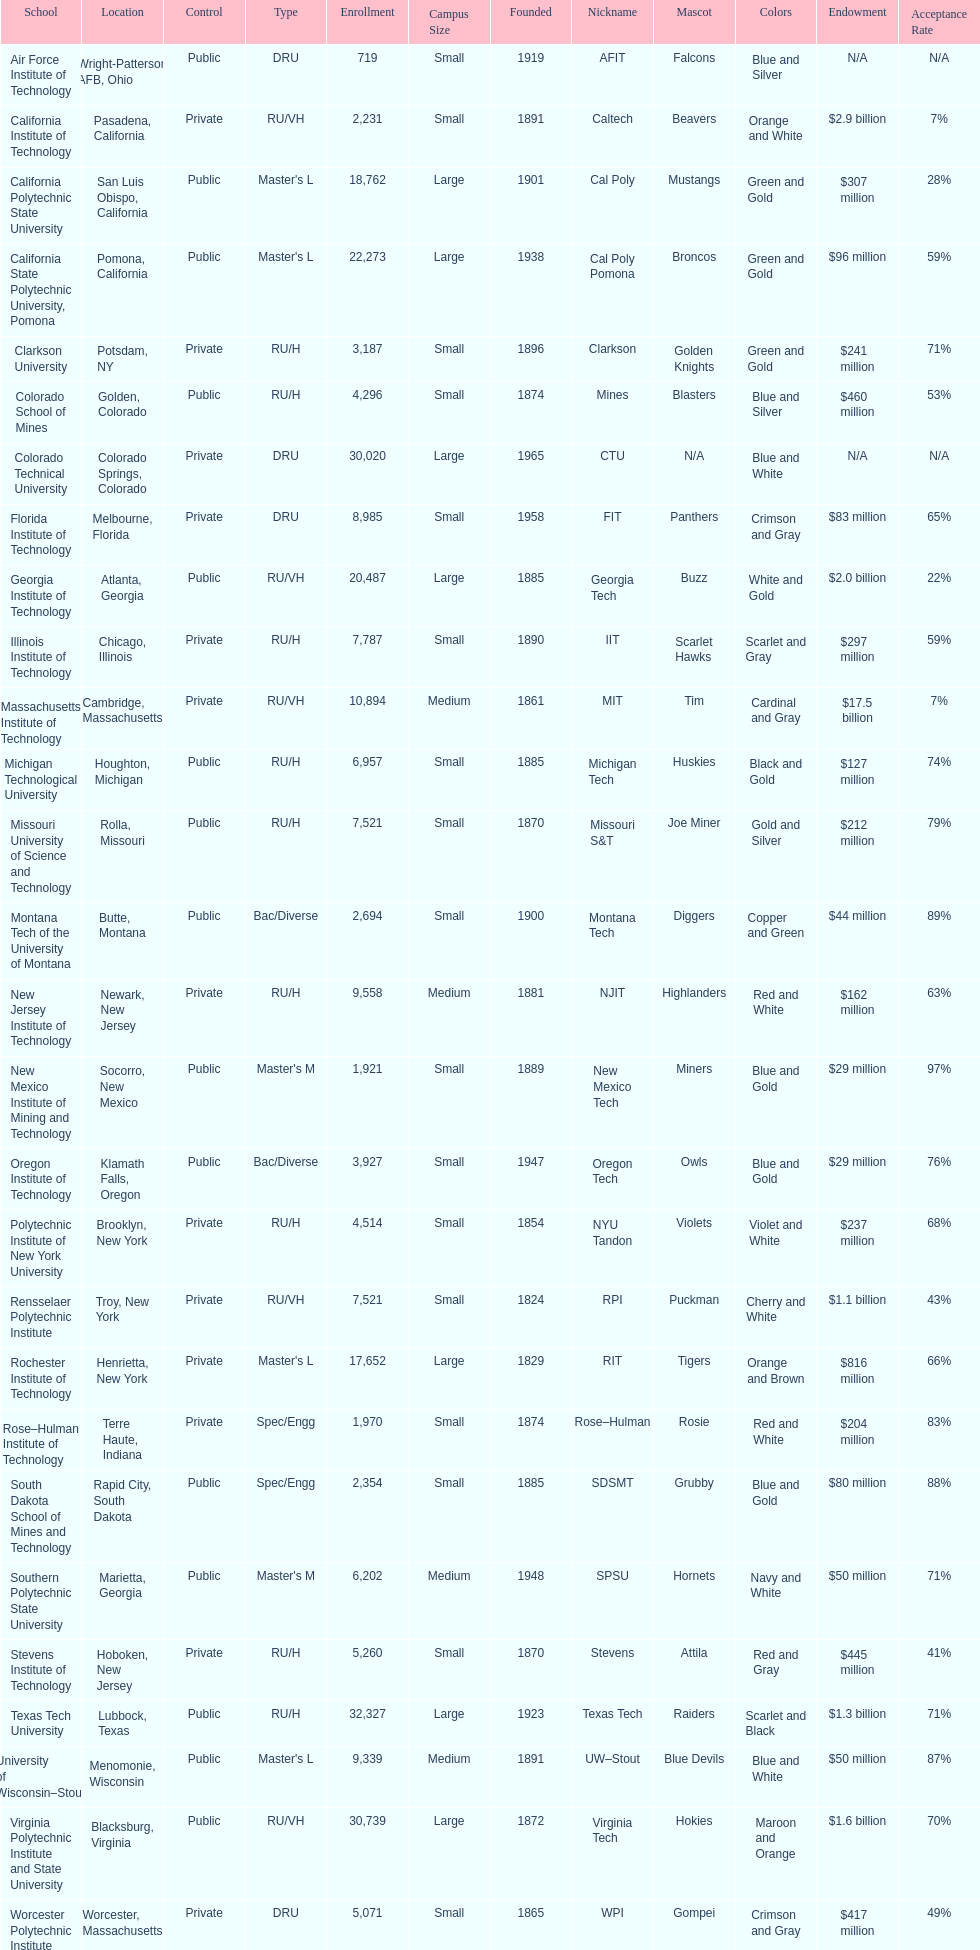What is the difference in enrollment between the top 2 schools listed in the table? 1512. 